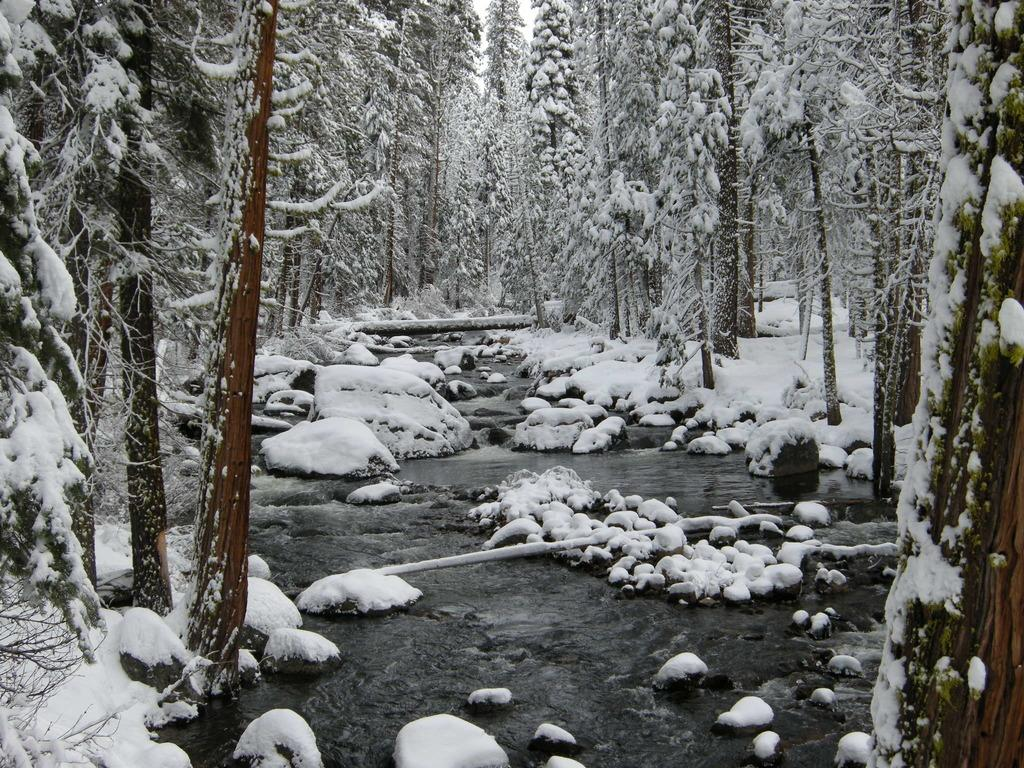What type of weather condition is depicted in the image? There is snow in the image, indicating a cold or wintery scene. What can be seen in the background of the image? There are trees in the background of the image. How many firemen are riding the horses in the image? There are no firemen or horses present in the image; it features snow and trees. 